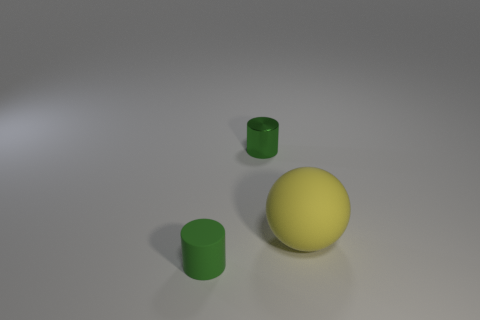Are there any tiny matte things that have the same shape as the tiny green metallic object?
Your response must be concise. Yes. What color is the cylinder that is the same size as the green shiny object?
Offer a very short reply. Green. There is a green object on the left side of the tiny metallic cylinder; what is it made of?
Offer a very short reply. Rubber. There is a small thing in front of the large yellow matte ball; does it have the same shape as the tiny object that is behind the small green matte object?
Offer a very short reply. Yes. Are there the same number of spheres that are behind the yellow matte thing and tiny purple shiny cylinders?
Offer a terse response. Yes. What number of large cyan blocks are made of the same material as the yellow ball?
Provide a succinct answer. 0. The tiny cylinder that is the same material as the large yellow sphere is what color?
Your answer should be very brief. Green. There is a metal cylinder; is its size the same as the matte object in front of the yellow matte sphere?
Make the answer very short. Yes. What is the shape of the metal object?
Ensure brevity in your answer.  Cylinder. How many other small cylinders have the same color as the tiny rubber cylinder?
Make the answer very short. 1. 